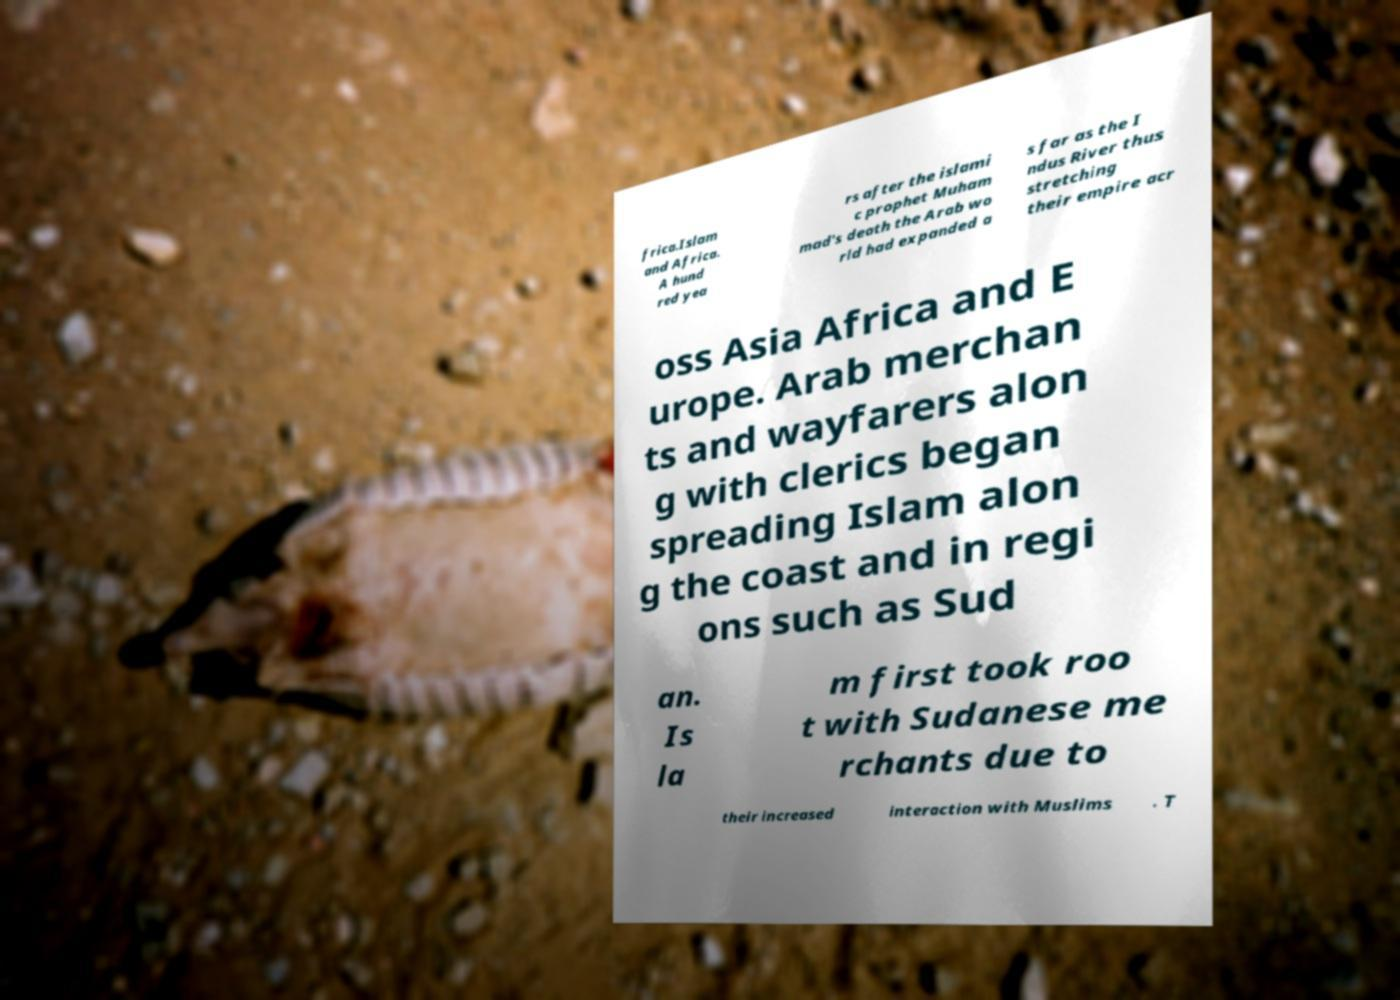Please identify and transcribe the text found in this image. frica.Islam and Africa. A hund red yea rs after the islami c prophet Muham mad's death the Arab wo rld had expanded a s far as the I ndus River thus stretching their empire acr oss Asia Africa and E urope. Arab merchan ts and wayfarers alon g with clerics began spreading Islam alon g the coast and in regi ons such as Sud an. Is la m first took roo t with Sudanese me rchants due to their increased interaction with Muslims . T 